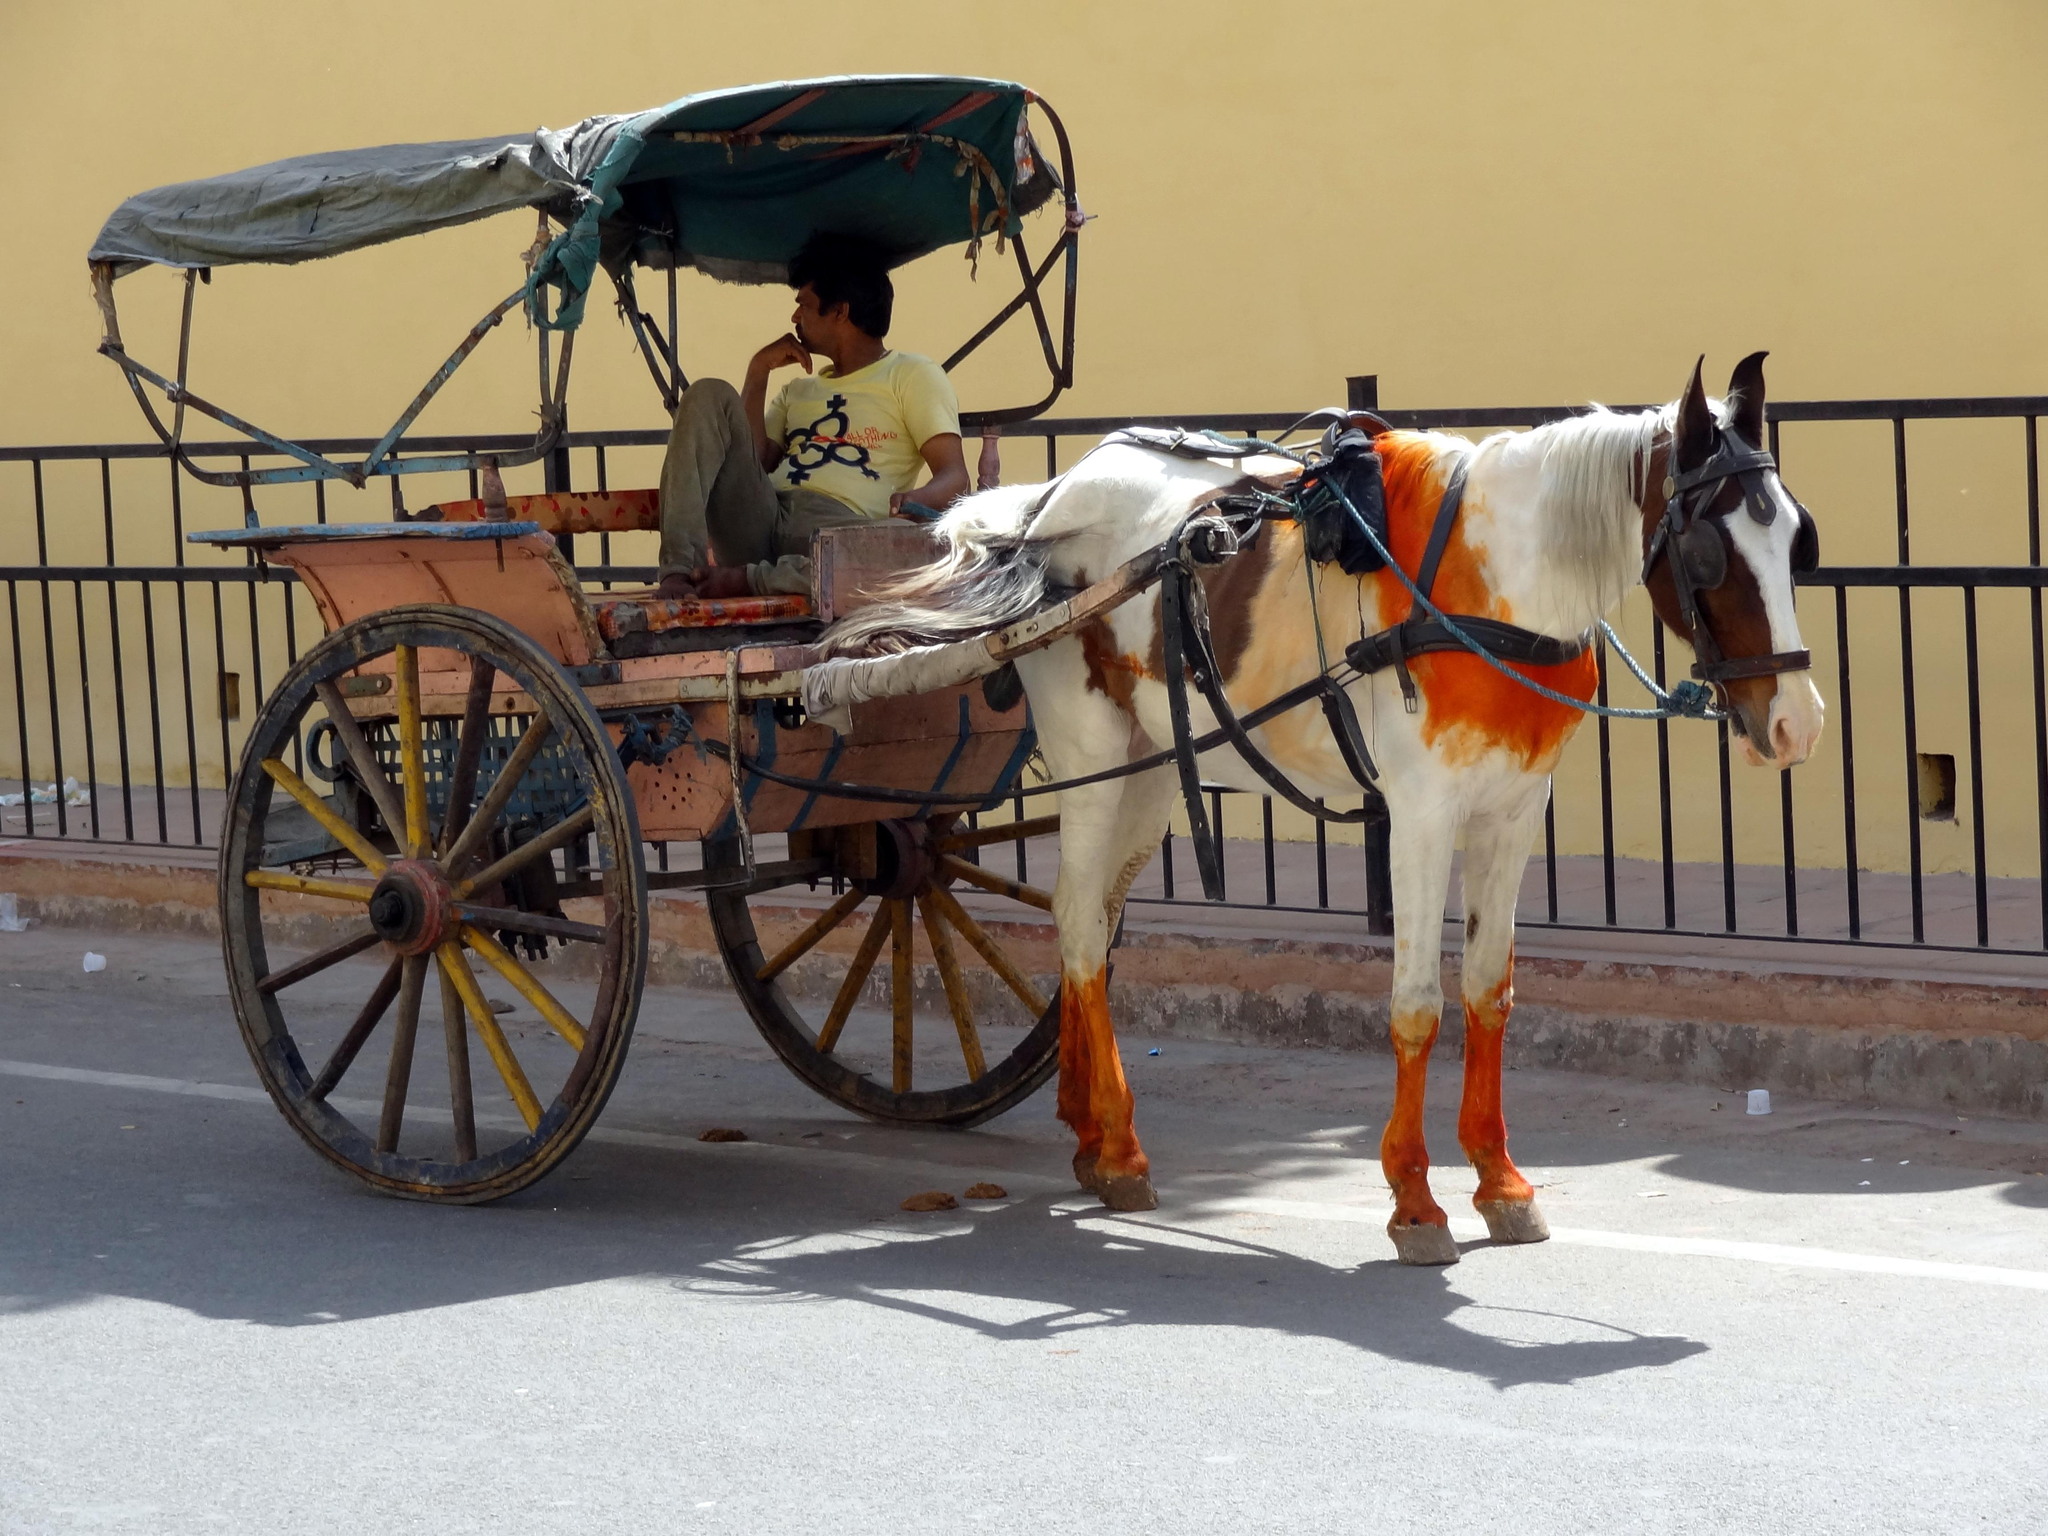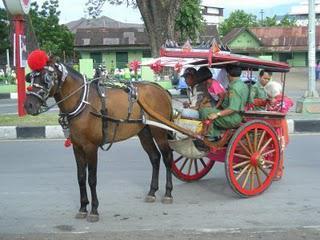The first image is the image on the left, the second image is the image on the right. Evaluate the accuracy of this statement regarding the images: "There is only one person riding in the cart in one of the images.". Is it true? Answer yes or no. Yes. The first image is the image on the left, the second image is the image on the right. For the images shown, is this caption "The image on the ride has a horse with a red tassel on its head." true? Answer yes or no. Yes. 